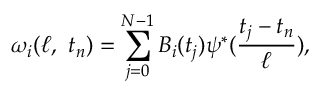<formula> <loc_0><loc_0><loc_500><loc_500>\omega _ { i } ( \ell , t _ { n } ) = \sum _ { j = 0 } ^ { N - 1 } B _ { i } ( t _ { j } ) \psi ^ { \ast } ( \frac { t _ { j } - t _ { n } } { \ell } ) ,</formula> 